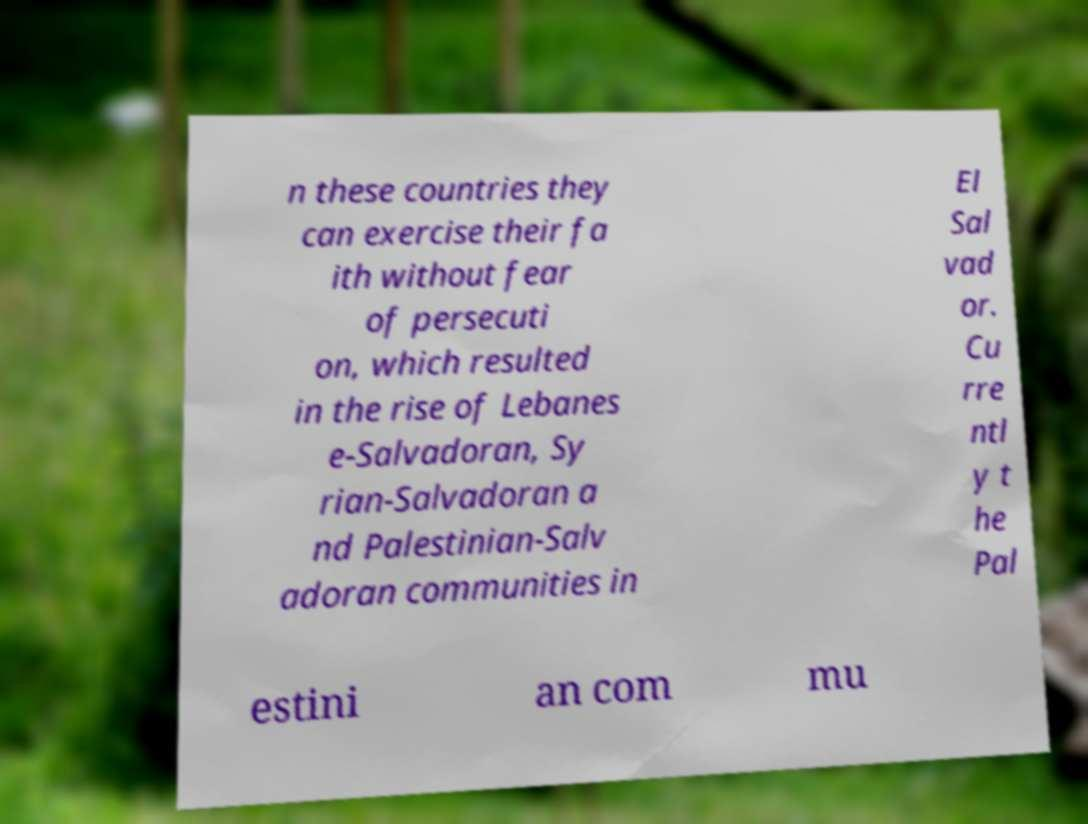Could you extract and type out the text from this image? n these countries they can exercise their fa ith without fear of persecuti on, which resulted in the rise of Lebanes e-Salvadoran, Sy rian-Salvadoran a nd Palestinian-Salv adoran communities in El Sal vad or. Cu rre ntl y t he Pal estini an com mu 